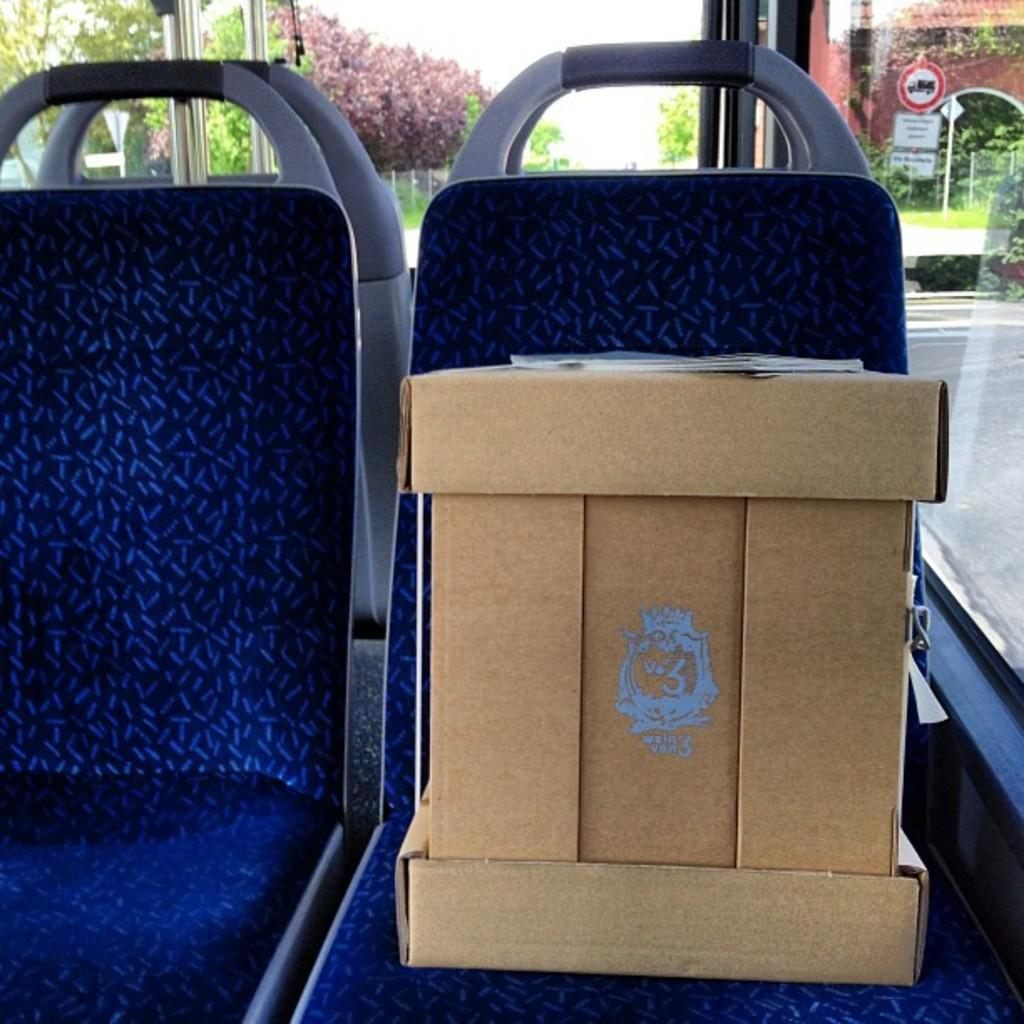What type of furniture is present in the image? There are chairs in the image. What color are the chairs? The chairs are blue in color. Where are the chairs located? The chairs are inside a vehicle. What can be seen in the background of the image? There are trees visible in the image. What type of tool is the carpenter using on the dog in the image? There is no carpenter, tool, or dog present in the image. 